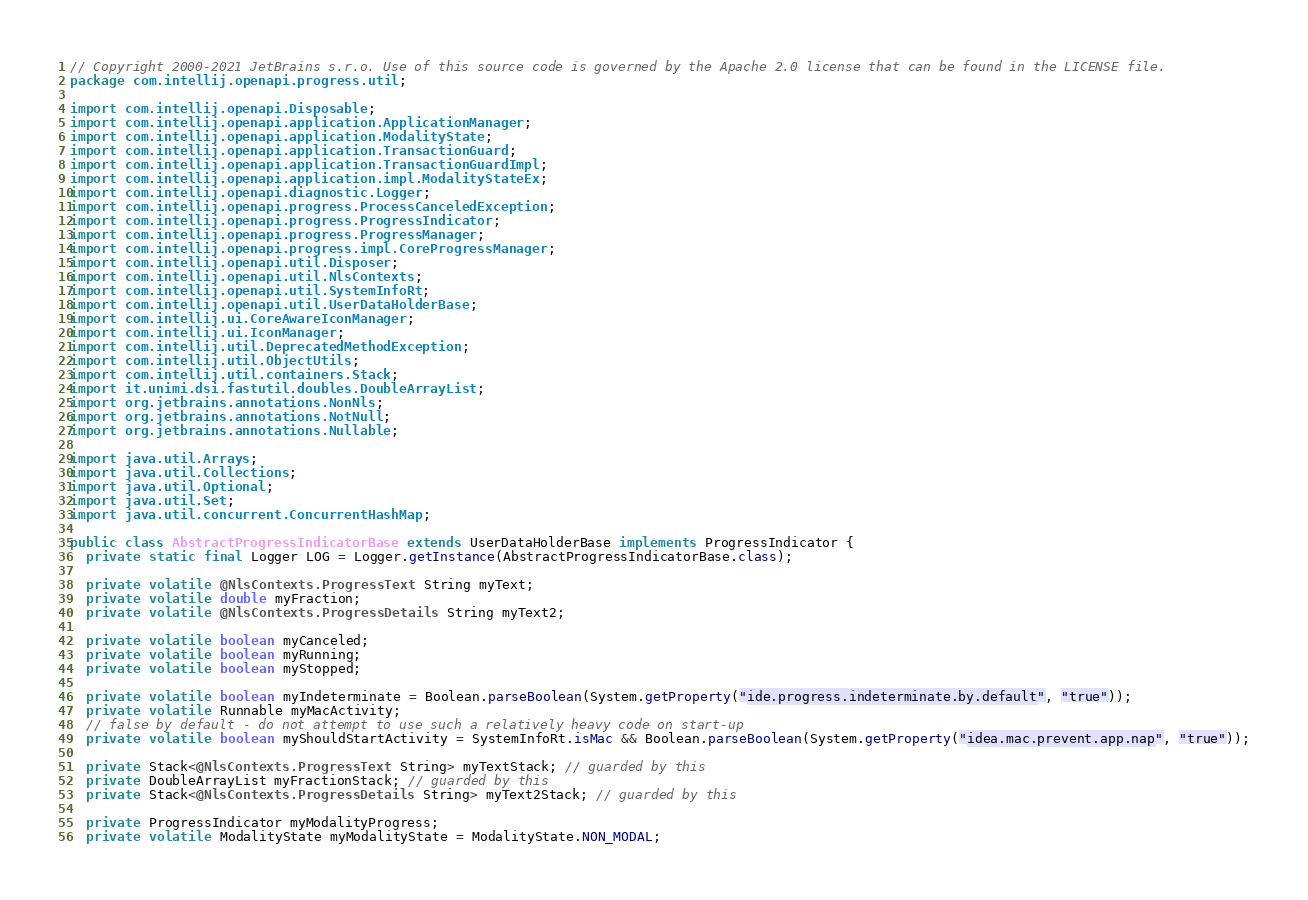Convert code to text. <code><loc_0><loc_0><loc_500><loc_500><_Java_>// Copyright 2000-2021 JetBrains s.r.o. Use of this source code is governed by the Apache 2.0 license that can be found in the LICENSE file.
package com.intellij.openapi.progress.util;

import com.intellij.openapi.Disposable;
import com.intellij.openapi.application.ApplicationManager;
import com.intellij.openapi.application.ModalityState;
import com.intellij.openapi.application.TransactionGuard;
import com.intellij.openapi.application.TransactionGuardImpl;
import com.intellij.openapi.application.impl.ModalityStateEx;
import com.intellij.openapi.diagnostic.Logger;
import com.intellij.openapi.progress.ProcessCanceledException;
import com.intellij.openapi.progress.ProgressIndicator;
import com.intellij.openapi.progress.ProgressManager;
import com.intellij.openapi.progress.impl.CoreProgressManager;
import com.intellij.openapi.util.Disposer;
import com.intellij.openapi.util.NlsContexts;
import com.intellij.openapi.util.SystemInfoRt;
import com.intellij.openapi.util.UserDataHolderBase;
import com.intellij.ui.CoreAwareIconManager;
import com.intellij.ui.IconManager;
import com.intellij.util.DeprecatedMethodException;
import com.intellij.util.ObjectUtils;
import com.intellij.util.containers.Stack;
import it.unimi.dsi.fastutil.doubles.DoubleArrayList;
import org.jetbrains.annotations.NonNls;
import org.jetbrains.annotations.NotNull;
import org.jetbrains.annotations.Nullable;

import java.util.Arrays;
import java.util.Collections;
import java.util.Optional;
import java.util.Set;
import java.util.concurrent.ConcurrentHashMap;

public class AbstractProgressIndicatorBase extends UserDataHolderBase implements ProgressIndicator {
  private static final Logger LOG = Logger.getInstance(AbstractProgressIndicatorBase.class);

  private volatile @NlsContexts.ProgressText String myText;
  private volatile double myFraction;
  private volatile @NlsContexts.ProgressDetails String myText2;

  private volatile boolean myCanceled;
  private volatile boolean myRunning;
  private volatile boolean myStopped;

  private volatile boolean myIndeterminate = Boolean.parseBoolean(System.getProperty("ide.progress.indeterminate.by.default", "true"));
  private volatile Runnable myMacActivity;
  // false by default - do not attempt to use such a relatively heavy code on start-up
  private volatile boolean myShouldStartActivity = SystemInfoRt.isMac && Boolean.parseBoolean(System.getProperty("idea.mac.prevent.app.nap", "true"));

  private Stack<@NlsContexts.ProgressText String> myTextStack; // guarded by this
  private DoubleArrayList myFractionStack; // guarded by this
  private Stack<@NlsContexts.ProgressDetails String> myText2Stack; // guarded by this

  private ProgressIndicator myModalityProgress;
  private volatile ModalityState myModalityState = ModalityState.NON_MODAL;</code> 